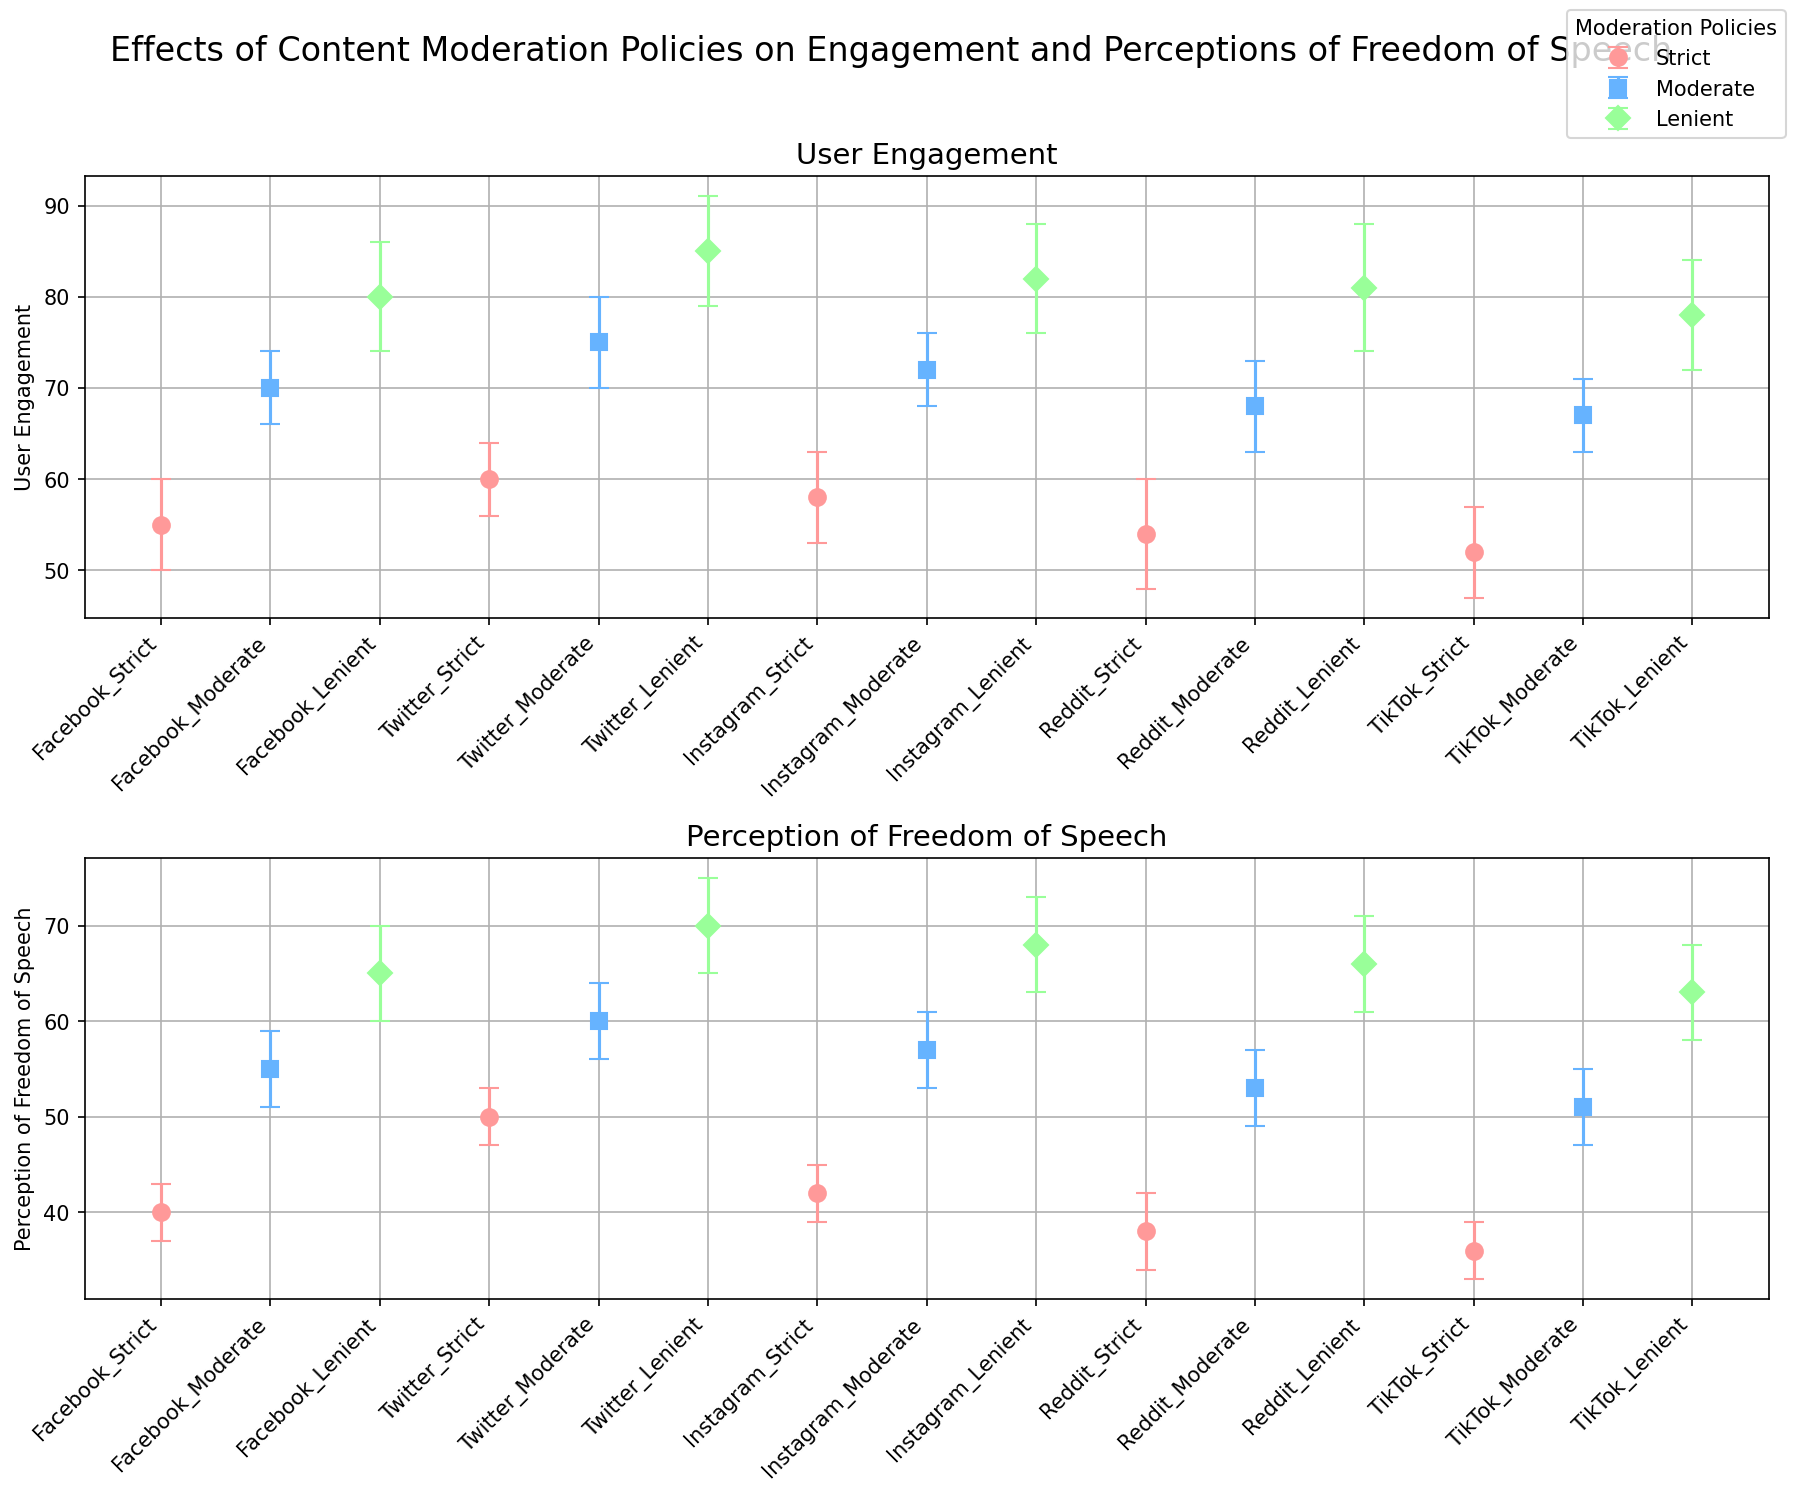What's the highest user engagement value across all platforms? To find the highest user engagement value, scan the User Engagement (Mean) values across all platforms and moderation policies. The highest value is 85 for Twitter with a Lenient policy.
Answer: 85 Which platform shows the lowest perception of freedom of speech under strict content moderation? Identify the Perception of Freedom of Speech (Mean) values for all platforms under a Strict policy. The lowest value is 36 on TikTok.
Answer: TikTok Compare the user engagement between Facebook and Reddit under moderate content moderation. Which platform has higher engagement? Look at the User Engagement (Mean) values for both Facebook and Reddit with a Moderate policy. Facebook has a mean of 70, while Reddit has a mean of 68. Thus, Facebook has higher engagement.
Answer: Facebook What is the sum of engagement values for Instagram under all three content moderation policies? Add the User Engagement (Mean) values for Instagram under Strict (58), Moderate (72), and Lenient (82) policies. The sum is 58 + 72 + 82 = 212.
Answer: 212 Which moderation policy generally corresponds to the highest perception of freedom of speech across all platforms? Evaluate the Perception of Freedom of Speech (Mean) values for all platforms under Lenient, Moderate, and Strict policies. The Lenient policy generally has the highest values, consistently being the highest for all platforms.
Answer: Lenient Which platform has the smallest error margin for user engagement under moderate content moderation? Identify the User Engagement (Error Margin) values for moderate policy across all platforms. The smallest error margin is 4, which is consistent across Facebook, Instagram, and TikTok.
Answer: Facebook, Instagram, TikTok Is there a platform where user engagement under lenient content moderation is below 80? Check the User Engagement (Mean) values for all platforms under a Lenient policy. No platform has a mean engagement value below 80 under lenient policy.
Answer: No What is the difference in perceptions of freedom of speech on Twitter between strict and lenient content moderation policies? Subtract the Perception of Freedom of Speech (Mean) value under strict policy (50) from that under lenient policy (70) for Twitter. The difference is 70 - 50 = 20.
Answer: 20 For Reddit, what is the percentage increase in user engagement from strict to lenient content moderation policy? Calculate the increase in engagement from Strict (54) to Lenient (81) and then find the percentage increase: (81 - 54) / 54 * 100%. The calculation yields a percentage increase of (27 / 54) * 100% = 50%.
Answer: 50% Which platform has the most significant improvement in perception of freedom of speech when switching from strict to lenient policies? Compute the difference between lenient and strict perception means for each platform, then identify the highest difference. Facebook has the most significant improvement from 40 to 65, a difference of 25.
Answer: Facebook 